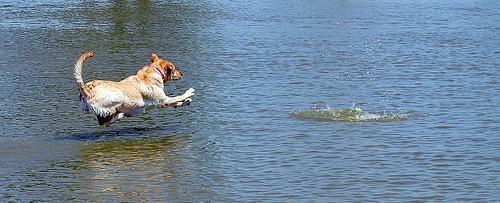How many dogs are pictured?
Give a very brief answer. 1. 